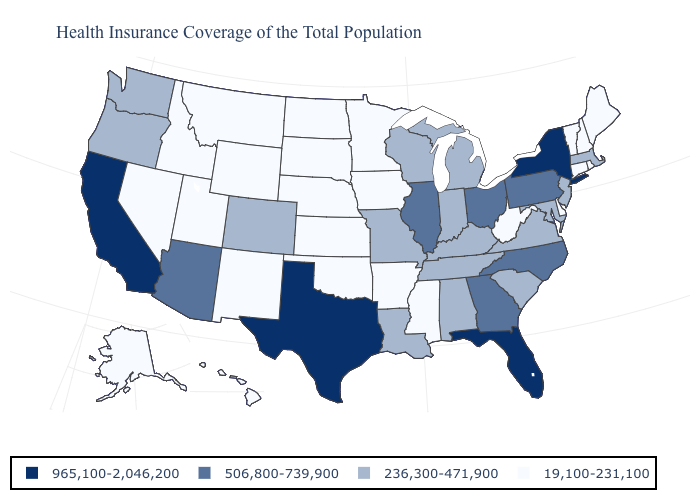Which states hav the highest value in the MidWest?
Answer briefly. Illinois, Ohio. What is the highest value in the USA?
Be succinct. 965,100-2,046,200. What is the value of Colorado?
Quick response, please. 236,300-471,900. Name the states that have a value in the range 236,300-471,900?
Give a very brief answer. Alabama, Colorado, Indiana, Kentucky, Louisiana, Maryland, Massachusetts, Michigan, Missouri, New Jersey, Oregon, South Carolina, Tennessee, Virginia, Washington, Wisconsin. Name the states that have a value in the range 236,300-471,900?
Be succinct. Alabama, Colorado, Indiana, Kentucky, Louisiana, Maryland, Massachusetts, Michigan, Missouri, New Jersey, Oregon, South Carolina, Tennessee, Virginia, Washington, Wisconsin. Name the states that have a value in the range 19,100-231,100?
Quick response, please. Alaska, Arkansas, Connecticut, Delaware, Hawaii, Idaho, Iowa, Kansas, Maine, Minnesota, Mississippi, Montana, Nebraska, Nevada, New Hampshire, New Mexico, North Dakota, Oklahoma, Rhode Island, South Dakota, Utah, Vermont, West Virginia, Wyoming. Among the states that border Tennessee , which have the highest value?
Short answer required. Georgia, North Carolina. What is the highest value in the MidWest ?
Answer briefly. 506,800-739,900. What is the value of Maine?
Quick response, please. 19,100-231,100. What is the value of Idaho?
Be succinct. 19,100-231,100. What is the lowest value in the West?
Be succinct. 19,100-231,100. What is the value of South Dakota?
Quick response, please. 19,100-231,100. Name the states that have a value in the range 236,300-471,900?
Give a very brief answer. Alabama, Colorado, Indiana, Kentucky, Louisiana, Maryland, Massachusetts, Michigan, Missouri, New Jersey, Oregon, South Carolina, Tennessee, Virginia, Washington, Wisconsin. Name the states that have a value in the range 19,100-231,100?
Answer briefly. Alaska, Arkansas, Connecticut, Delaware, Hawaii, Idaho, Iowa, Kansas, Maine, Minnesota, Mississippi, Montana, Nebraska, Nevada, New Hampshire, New Mexico, North Dakota, Oklahoma, Rhode Island, South Dakota, Utah, Vermont, West Virginia, Wyoming. Name the states that have a value in the range 506,800-739,900?
Be succinct. Arizona, Georgia, Illinois, North Carolina, Ohio, Pennsylvania. 